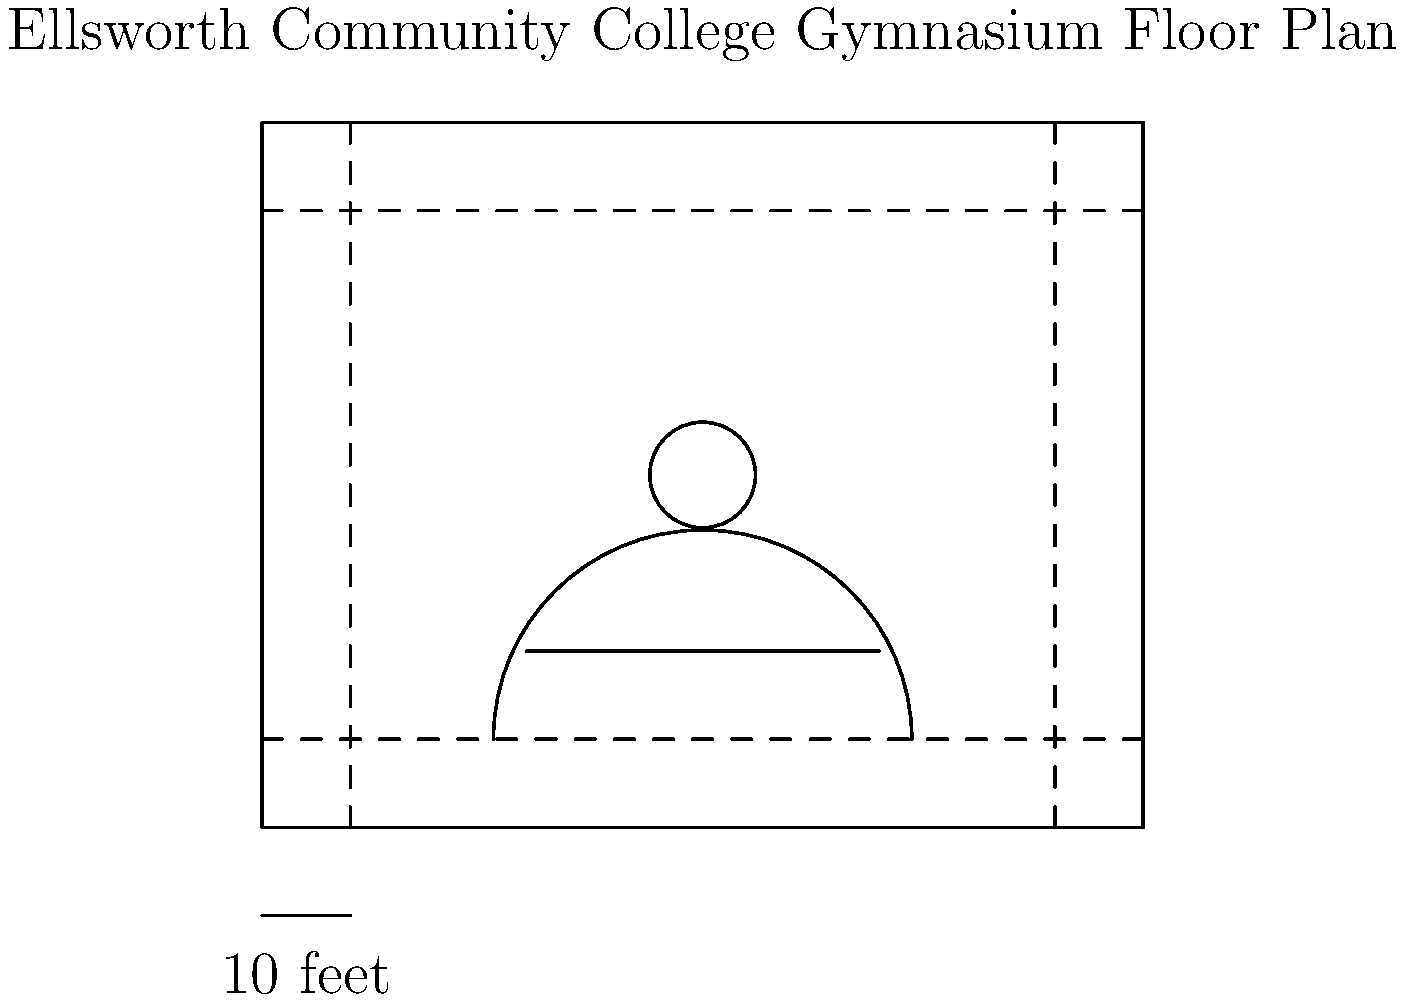Based on the scaled floor plan of the Ellsworth Community College gymnasium shown above, what is the approximate area of the main playing court in square feet? (Assume the main playing court extends from sideline to sideline and baseline to baseline.) To calculate the area of the main playing court, we need to follow these steps:

1. Determine the scale of the floor plan:
   The scale indicator shows that 1 unit in the diagram represents 10 feet.

2. Measure the length of the court:
   From sideline to sideline, the court spans 8 units.
   $8 \times 10 = 80$ feet

3. Measure the width of the court:
   From baseline to baseline, the court spans 6 units.
   $6 \times 10 = 60$ feet

4. Calculate the area:
   Area = length $\times$ width
   $$ A = 80 \text{ ft} \times 60 \text{ ft} = 4,800 \text{ sq ft} $$

Therefore, the approximate area of the main playing court is 4,800 square feet.
Answer: 4,800 sq ft 